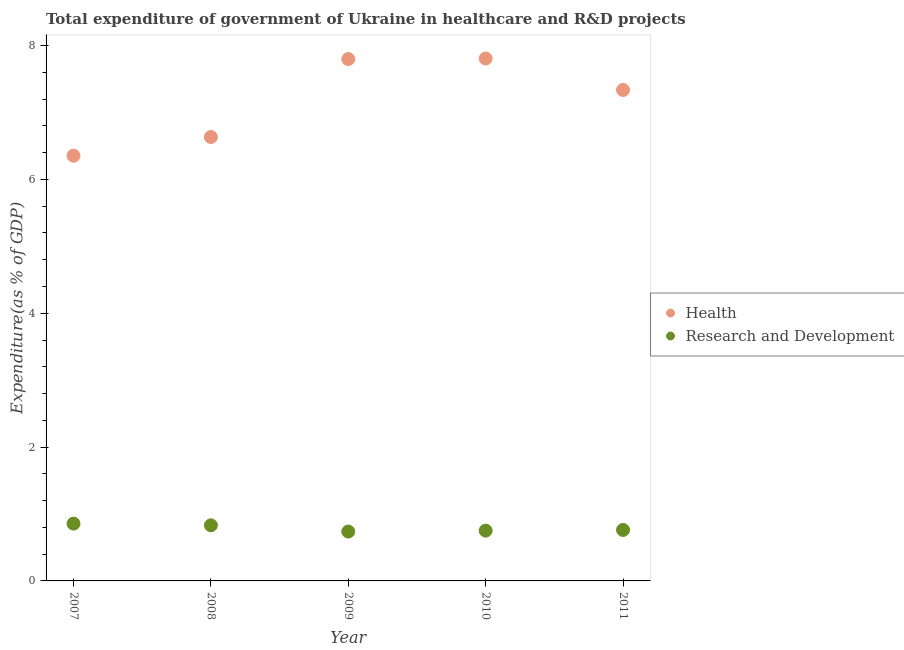How many different coloured dotlines are there?
Make the answer very short. 2. What is the expenditure in healthcare in 2008?
Provide a short and direct response. 6.63. Across all years, what is the maximum expenditure in healthcare?
Provide a short and direct response. 7.81. Across all years, what is the minimum expenditure in r&d?
Provide a short and direct response. 0.74. What is the total expenditure in r&d in the graph?
Your response must be concise. 3.94. What is the difference between the expenditure in r&d in 2008 and that in 2009?
Provide a succinct answer. 0.09. What is the difference between the expenditure in healthcare in 2011 and the expenditure in r&d in 2008?
Provide a short and direct response. 6.51. What is the average expenditure in r&d per year?
Make the answer very short. 0.79. In the year 2010, what is the difference between the expenditure in healthcare and expenditure in r&d?
Ensure brevity in your answer.  7.06. What is the ratio of the expenditure in r&d in 2007 to that in 2010?
Provide a short and direct response. 1.14. Is the expenditure in healthcare in 2010 less than that in 2011?
Your response must be concise. No. Is the difference between the expenditure in r&d in 2009 and 2010 greater than the difference between the expenditure in healthcare in 2009 and 2010?
Offer a very short reply. No. What is the difference between the highest and the second highest expenditure in r&d?
Make the answer very short. 0.03. What is the difference between the highest and the lowest expenditure in r&d?
Keep it short and to the point. 0.12. In how many years, is the expenditure in r&d greater than the average expenditure in r&d taken over all years?
Make the answer very short. 2. Is the sum of the expenditure in r&d in 2007 and 2008 greater than the maximum expenditure in healthcare across all years?
Provide a succinct answer. No. Is the expenditure in r&d strictly greater than the expenditure in healthcare over the years?
Give a very brief answer. No. Is the expenditure in healthcare strictly less than the expenditure in r&d over the years?
Your answer should be very brief. No. What is the difference between two consecutive major ticks on the Y-axis?
Provide a succinct answer. 2. Does the graph contain any zero values?
Your response must be concise. No. How many legend labels are there?
Provide a short and direct response. 2. What is the title of the graph?
Your answer should be compact. Total expenditure of government of Ukraine in healthcare and R&D projects. Does "Ages 15-24" appear as one of the legend labels in the graph?
Ensure brevity in your answer.  No. What is the label or title of the Y-axis?
Your answer should be very brief. Expenditure(as % of GDP). What is the Expenditure(as % of GDP) in Health in 2007?
Your answer should be compact. 6.36. What is the Expenditure(as % of GDP) in Research and Development in 2007?
Your response must be concise. 0.86. What is the Expenditure(as % of GDP) in Health in 2008?
Offer a terse response. 6.63. What is the Expenditure(as % of GDP) in Research and Development in 2008?
Provide a succinct answer. 0.83. What is the Expenditure(as % of GDP) in Health in 2009?
Provide a short and direct response. 7.8. What is the Expenditure(as % of GDP) in Research and Development in 2009?
Your answer should be compact. 0.74. What is the Expenditure(as % of GDP) in Health in 2010?
Keep it short and to the point. 7.81. What is the Expenditure(as % of GDP) of Research and Development in 2010?
Give a very brief answer. 0.75. What is the Expenditure(as % of GDP) in Health in 2011?
Your answer should be compact. 7.34. What is the Expenditure(as % of GDP) in Research and Development in 2011?
Keep it short and to the point. 0.76. Across all years, what is the maximum Expenditure(as % of GDP) of Health?
Offer a very short reply. 7.81. Across all years, what is the maximum Expenditure(as % of GDP) of Research and Development?
Provide a short and direct response. 0.86. Across all years, what is the minimum Expenditure(as % of GDP) in Health?
Give a very brief answer. 6.36. Across all years, what is the minimum Expenditure(as % of GDP) in Research and Development?
Ensure brevity in your answer.  0.74. What is the total Expenditure(as % of GDP) of Health in the graph?
Ensure brevity in your answer.  35.93. What is the total Expenditure(as % of GDP) of Research and Development in the graph?
Your answer should be very brief. 3.94. What is the difference between the Expenditure(as % of GDP) of Health in 2007 and that in 2008?
Provide a succinct answer. -0.28. What is the difference between the Expenditure(as % of GDP) in Research and Development in 2007 and that in 2008?
Your answer should be compact. 0.03. What is the difference between the Expenditure(as % of GDP) of Health in 2007 and that in 2009?
Provide a succinct answer. -1.44. What is the difference between the Expenditure(as % of GDP) in Research and Development in 2007 and that in 2009?
Your answer should be very brief. 0.12. What is the difference between the Expenditure(as % of GDP) of Health in 2007 and that in 2010?
Keep it short and to the point. -1.45. What is the difference between the Expenditure(as % of GDP) in Research and Development in 2007 and that in 2010?
Give a very brief answer. 0.1. What is the difference between the Expenditure(as % of GDP) in Health in 2007 and that in 2011?
Your answer should be very brief. -0.98. What is the difference between the Expenditure(as % of GDP) of Research and Development in 2007 and that in 2011?
Provide a short and direct response. 0.09. What is the difference between the Expenditure(as % of GDP) of Health in 2008 and that in 2009?
Provide a short and direct response. -1.17. What is the difference between the Expenditure(as % of GDP) in Research and Development in 2008 and that in 2009?
Provide a short and direct response. 0.09. What is the difference between the Expenditure(as % of GDP) in Health in 2008 and that in 2010?
Ensure brevity in your answer.  -1.17. What is the difference between the Expenditure(as % of GDP) of Research and Development in 2008 and that in 2010?
Ensure brevity in your answer.  0.08. What is the difference between the Expenditure(as % of GDP) in Health in 2008 and that in 2011?
Ensure brevity in your answer.  -0.7. What is the difference between the Expenditure(as % of GDP) of Research and Development in 2008 and that in 2011?
Ensure brevity in your answer.  0.07. What is the difference between the Expenditure(as % of GDP) of Health in 2009 and that in 2010?
Make the answer very short. -0.01. What is the difference between the Expenditure(as % of GDP) in Research and Development in 2009 and that in 2010?
Provide a succinct answer. -0.01. What is the difference between the Expenditure(as % of GDP) of Health in 2009 and that in 2011?
Make the answer very short. 0.46. What is the difference between the Expenditure(as % of GDP) in Research and Development in 2009 and that in 2011?
Provide a succinct answer. -0.02. What is the difference between the Expenditure(as % of GDP) of Health in 2010 and that in 2011?
Offer a very short reply. 0.47. What is the difference between the Expenditure(as % of GDP) in Research and Development in 2010 and that in 2011?
Give a very brief answer. -0.01. What is the difference between the Expenditure(as % of GDP) of Health in 2007 and the Expenditure(as % of GDP) of Research and Development in 2008?
Provide a short and direct response. 5.52. What is the difference between the Expenditure(as % of GDP) of Health in 2007 and the Expenditure(as % of GDP) of Research and Development in 2009?
Your answer should be very brief. 5.62. What is the difference between the Expenditure(as % of GDP) in Health in 2007 and the Expenditure(as % of GDP) in Research and Development in 2010?
Provide a short and direct response. 5.6. What is the difference between the Expenditure(as % of GDP) in Health in 2007 and the Expenditure(as % of GDP) in Research and Development in 2011?
Provide a short and direct response. 5.59. What is the difference between the Expenditure(as % of GDP) in Health in 2008 and the Expenditure(as % of GDP) in Research and Development in 2009?
Offer a very short reply. 5.9. What is the difference between the Expenditure(as % of GDP) in Health in 2008 and the Expenditure(as % of GDP) in Research and Development in 2010?
Offer a terse response. 5.88. What is the difference between the Expenditure(as % of GDP) of Health in 2008 and the Expenditure(as % of GDP) of Research and Development in 2011?
Your answer should be very brief. 5.87. What is the difference between the Expenditure(as % of GDP) in Health in 2009 and the Expenditure(as % of GDP) in Research and Development in 2010?
Provide a short and direct response. 7.05. What is the difference between the Expenditure(as % of GDP) in Health in 2009 and the Expenditure(as % of GDP) in Research and Development in 2011?
Provide a short and direct response. 7.04. What is the difference between the Expenditure(as % of GDP) of Health in 2010 and the Expenditure(as % of GDP) of Research and Development in 2011?
Ensure brevity in your answer.  7.05. What is the average Expenditure(as % of GDP) in Health per year?
Give a very brief answer. 7.19. What is the average Expenditure(as % of GDP) in Research and Development per year?
Offer a terse response. 0.79. In the year 2007, what is the difference between the Expenditure(as % of GDP) in Health and Expenditure(as % of GDP) in Research and Development?
Your response must be concise. 5.5. In the year 2008, what is the difference between the Expenditure(as % of GDP) of Health and Expenditure(as % of GDP) of Research and Development?
Ensure brevity in your answer.  5.8. In the year 2009, what is the difference between the Expenditure(as % of GDP) in Health and Expenditure(as % of GDP) in Research and Development?
Offer a terse response. 7.06. In the year 2010, what is the difference between the Expenditure(as % of GDP) in Health and Expenditure(as % of GDP) in Research and Development?
Keep it short and to the point. 7.06. In the year 2011, what is the difference between the Expenditure(as % of GDP) of Health and Expenditure(as % of GDP) of Research and Development?
Provide a succinct answer. 6.58. What is the ratio of the Expenditure(as % of GDP) of Health in 2007 to that in 2008?
Your response must be concise. 0.96. What is the ratio of the Expenditure(as % of GDP) of Research and Development in 2007 to that in 2008?
Your response must be concise. 1.03. What is the ratio of the Expenditure(as % of GDP) of Health in 2007 to that in 2009?
Your response must be concise. 0.81. What is the ratio of the Expenditure(as % of GDP) of Research and Development in 2007 to that in 2009?
Give a very brief answer. 1.16. What is the ratio of the Expenditure(as % of GDP) in Health in 2007 to that in 2010?
Ensure brevity in your answer.  0.81. What is the ratio of the Expenditure(as % of GDP) in Research and Development in 2007 to that in 2010?
Give a very brief answer. 1.14. What is the ratio of the Expenditure(as % of GDP) in Health in 2007 to that in 2011?
Provide a short and direct response. 0.87. What is the ratio of the Expenditure(as % of GDP) of Research and Development in 2007 to that in 2011?
Your answer should be compact. 1.12. What is the ratio of the Expenditure(as % of GDP) in Health in 2008 to that in 2009?
Your answer should be very brief. 0.85. What is the ratio of the Expenditure(as % of GDP) of Research and Development in 2008 to that in 2009?
Your answer should be compact. 1.13. What is the ratio of the Expenditure(as % of GDP) of Health in 2008 to that in 2010?
Your answer should be very brief. 0.85. What is the ratio of the Expenditure(as % of GDP) of Research and Development in 2008 to that in 2010?
Offer a very short reply. 1.11. What is the ratio of the Expenditure(as % of GDP) in Health in 2008 to that in 2011?
Keep it short and to the point. 0.9. What is the ratio of the Expenditure(as % of GDP) in Research and Development in 2008 to that in 2011?
Provide a short and direct response. 1.09. What is the ratio of the Expenditure(as % of GDP) in Health in 2009 to that in 2010?
Provide a short and direct response. 1. What is the ratio of the Expenditure(as % of GDP) of Research and Development in 2009 to that in 2010?
Your answer should be very brief. 0.98. What is the ratio of the Expenditure(as % of GDP) of Health in 2009 to that in 2011?
Offer a terse response. 1.06. What is the ratio of the Expenditure(as % of GDP) in Research and Development in 2009 to that in 2011?
Offer a terse response. 0.97. What is the ratio of the Expenditure(as % of GDP) in Health in 2010 to that in 2011?
Make the answer very short. 1.06. What is the ratio of the Expenditure(as % of GDP) in Research and Development in 2010 to that in 2011?
Your answer should be very brief. 0.99. What is the difference between the highest and the second highest Expenditure(as % of GDP) in Health?
Provide a succinct answer. 0.01. What is the difference between the highest and the second highest Expenditure(as % of GDP) in Research and Development?
Provide a short and direct response. 0.03. What is the difference between the highest and the lowest Expenditure(as % of GDP) of Health?
Provide a succinct answer. 1.45. What is the difference between the highest and the lowest Expenditure(as % of GDP) of Research and Development?
Offer a very short reply. 0.12. 